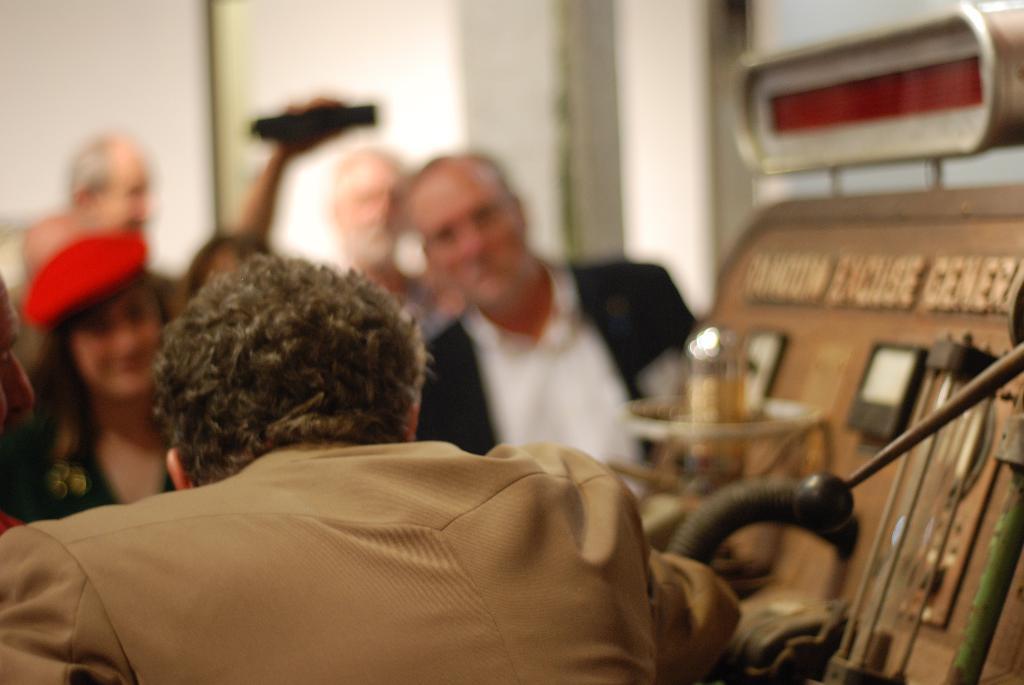Could you give a brief overview of what you see in this image? In this image we can see a few people. On the right we can see a generator board with text and the background is blurred. 